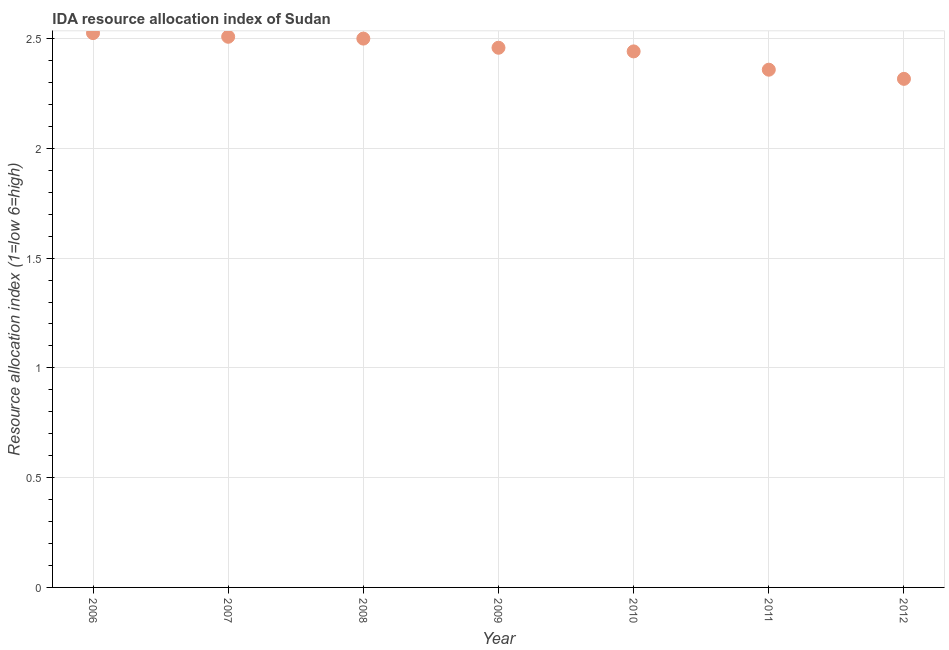What is the ida resource allocation index in 2007?
Your answer should be very brief. 2.51. Across all years, what is the maximum ida resource allocation index?
Keep it short and to the point. 2.52. Across all years, what is the minimum ida resource allocation index?
Offer a terse response. 2.32. In which year was the ida resource allocation index minimum?
Provide a short and direct response. 2012. What is the sum of the ida resource allocation index?
Give a very brief answer. 17.11. What is the difference between the ida resource allocation index in 2008 and 2012?
Give a very brief answer. 0.18. What is the average ida resource allocation index per year?
Your response must be concise. 2.44. What is the median ida resource allocation index?
Keep it short and to the point. 2.46. Do a majority of the years between 2009 and 2007 (inclusive) have ida resource allocation index greater than 2.1 ?
Make the answer very short. No. What is the ratio of the ida resource allocation index in 2010 to that in 2011?
Provide a succinct answer. 1.04. Is the ida resource allocation index in 2007 less than that in 2011?
Make the answer very short. No. Is the difference between the ida resource allocation index in 2009 and 2012 greater than the difference between any two years?
Offer a terse response. No. What is the difference between the highest and the second highest ida resource allocation index?
Make the answer very short. 0.02. Is the sum of the ida resource allocation index in 2010 and 2011 greater than the maximum ida resource allocation index across all years?
Your response must be concise. Yes. What is the difference between the highest and the lowest ida resource allocation index?
Offer a terse response. 0.21. Does the ida resource allocation index monotonically increase over the years?
Ensure brevity in your answer.  No. What is the difference between two consecutive major ticks on the Y-axis?
Offer a terse response. 0.5. Does the graph contain any zero values?
Provide a succinct answer. No. What is the title of the graph?
Provide a succinct answer. IDA resource allocation index of Sudan. What is the label or title of the X-axis?
Offer a terse response. Year. What is the label or title of the Y-axis?
Provide a succinct answer. Resource allocation index (1=low 6=high). What is the Resource allocation index (1=low 6=high) in 2006?
Provide a succinct answer. 2.52. What is the Resource allocation index (1=low 6=high) in 2007?
Give a very brief answer. 2.51. What is the Resource allocation index (1=low 6=high) in 2009?
Keep it short and to the point. 2.46. What is the Resource allocation index (1=low 6=high) in 2010?
Provide a short and direct response. 2.44. What is the Resource allocation index (1=low 6=high) in 2011?
Your answer should be compact. 2.36. What is the Resource allocation index (1=low 6=high) in 2012?
Your answer should be compact. 2.32. What is the difference between the Resource allocation index (1=low 6=high) in 2006 and 2007?
Your answer should be compact. 0.02. What is the difference between the Resource allocation index (1=low 6=high) in 2006 and 2008?
Provide a short and direct response. 0.03. What is the difference between the Resource allocation index (1=low 6=high) in 2006 and 2009?
Offer a very short reply. 0.07. What is the difference between the Resource allocation index (1=low 6=high) in 2006 and 2010?
Keep it short and to the point. 0.08. What is the difference between the Resource allocation index (1=low 6=high) in 2006 and 2011?
Your answer should be compact. 0.17. What is the difference between the Resource allocation index (1=low 6=high) in 2006 and 2012?
Ensure brevity in your answer.  0.21. What is the difference between the Resource allocation index (1=low 6=high) in 2007 and 2008?
Offer a very short reply. 0.01. What is the difference between the Resource allocation index (1=low 6=high) in 2007 and 2009?
Offer a terse response. 0.05. What is the difference between the Resource allocation index (1=low 6=high) in 2007 and 2010?
Give a very brief answer. 0.07. What is the difference between the Resource allocation index (1=low 6=high) in 2007 and 2011?
Your response must be concise. 0.15. What is the difference between the Resource allocation index (1=low 6=high) in 2007 and 2012?
Your answer should be very brief. 0.19. What is the difference between the Resource allocation index (1=low 6=high) in 2008 and 2009?
Your response must be concise. 0.04. What is the difference between the Resource allocation index (1=low 6=high) in 2008 and 2010?
Your answer should be compact. 0.06. What is the difference between the Resource allocation index (1=low 6=high) in 2008 and 2011?
Your response must be concise. 0.14. What is the difference between the Resource allocation index (1=low 6=high) in 2008 and 2012?
Offer a very short reply. 0.18. What is the difference between the Resource allocation index (1=low 6=high) in 2009 and 2010?
Give a very brief answer. 0.02. What is the difference between the Resource allocation index (1=low 6=high) in 2009 and 2012?
Ensure brevity in your answer.  0.14. What is the difference between the Resource allocation index (1=low 6=high) in 2010 and 2011?
Give a very brief answer. 0.08. What is the difference between the Resource allocation index (1=low 6=high) in 2011 and 2012?
Keep it short and to the point. 0.04. What is the ratio of the Resource allocation index (1=low 6=high) in 2006 to that in 2008?
Offer a terse response. 1.01. What is the ratio of the Resource allocation index (1=low 6=high) in 2006 to that in 2009?
Provide a short and direct response. 1.03. What is the ratio of the Resource allocation index (1=low 6=high) in 2006 to that in 2010?
Your response must be concise. 1.03. What is the ratio of the Resource allocation index (1=low 6=high) in 2006 to that in 2011?
Make the answer very short. 1.07. What is the ratio of the Resource allocation index (1=low 6=high) in 2006 to that in 2012?
Make the answer very short. 1.09. What is the ratio of the Resource allocation index (1=low 6=high) in 2007 to that in 2010?
Give a very brief answer. 1.03. What is the ratio of the Resource allocation index (1=low 6=high) in 2007 to that in 2011?
Give a very brief answer. 1.06. What is the ratio of the Resource allocation index (1=low 6=high) in 2007 to that in 2012?
Provide a succinct answer. 1.08. What is the ratio of the Resource allocation index (1=low 6=high) in 2008 to that in 2009?
Keep it short and to the point. 1.02. What is the ratio of the Resource allocation index (1=low 6=high) in 2008 to that in 2010?
Give a very brief answer. 1.02. What is the ratio of the Resource allocation index (1=low 6=high) in 2008 to that in 2011?
Provide a succinct answer. 1.06. What is the ratio of the Resource allocation index (1=low 6=high) in 2008 to that in 2012?
Ensure brevity in your answer.  1.08. What is the ratio of the Resource allocation index (1=low 6=high) in 2009 to that in 2010?
Your answer should be very brief. 1.01. What is the ratio of the Resource allocation index (1=low 6=high) in 2009 to that in 2011?
Ensure brevity in your answer.  1.04. What is the ratio of the Resource allocation index (1=low 6=high) in 2009 to that in 2012?
Your answer should be very brief. 1.06. What is the ratio of the Resource allocation index (1=low 6=high) in 2010 to that in 2011?
Provide a succinct answer. 1.03. What is the ratio of the Resource allocation index (1=low 6=high) in 2010 to that in 2012?
Give a very brief answer. 1.05. What is the ratio of the Resource allocation index (1=low 6=high) in 2011 to that in 2012?
Your response must be concise. 1.02. 